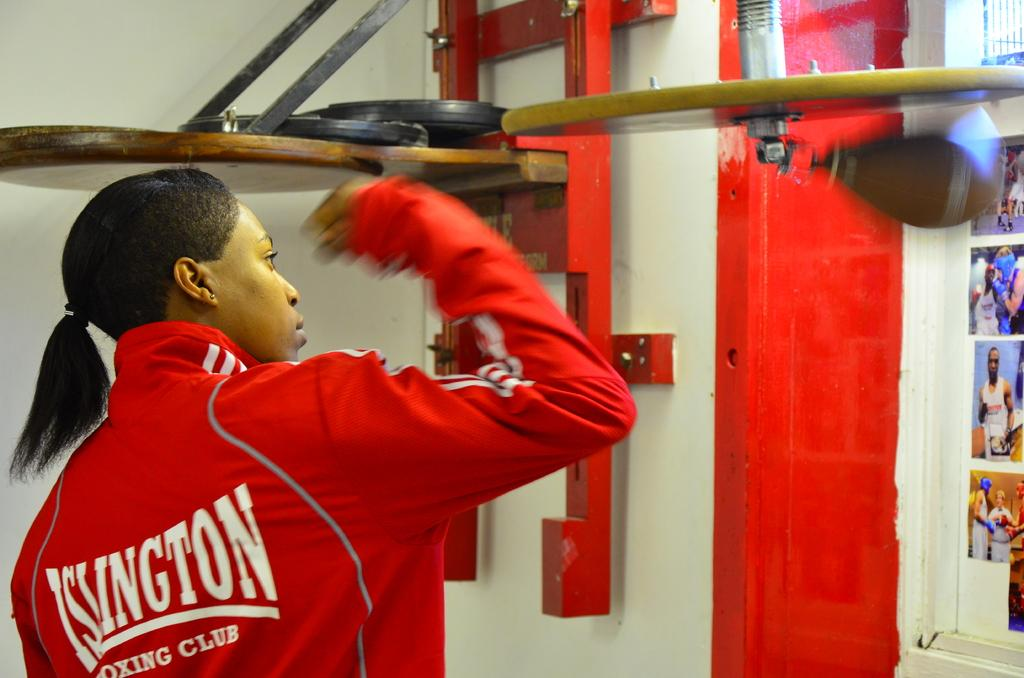Who is present in the image? There is a woman in the image. What is the woman wearing? The woman is wearing a red jacket. What can be seen on the right side of the image? There are photographs on the right side of the image. What is visible in the background of the image? There is a wall in the background of the image. How many pizzas are being served in the image? There are no pizzas present in the image. What type of play is the woman participating in the image? There is no play or any indication of a performance in the image. 